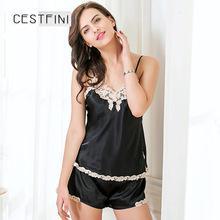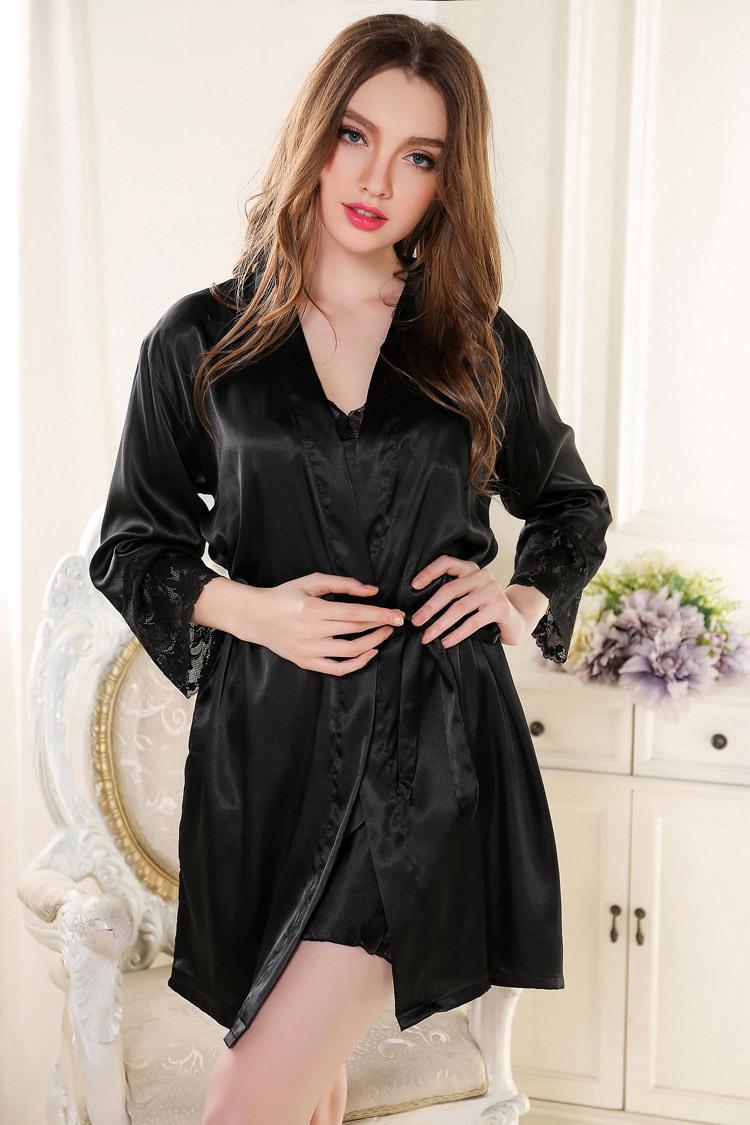The first image is the image on the left, the second image is the image on the right. Given the left and right images, does the statement "the pajamas have white piping accents around the pocket and shorts" hold true? Answer yes or no. No. The first image is the image on the left, the second image is the image on the right. Considering the images on both sides, is "One image shows a women wearing a night gown with a robe." valid? Answer yes or no. Yes. 